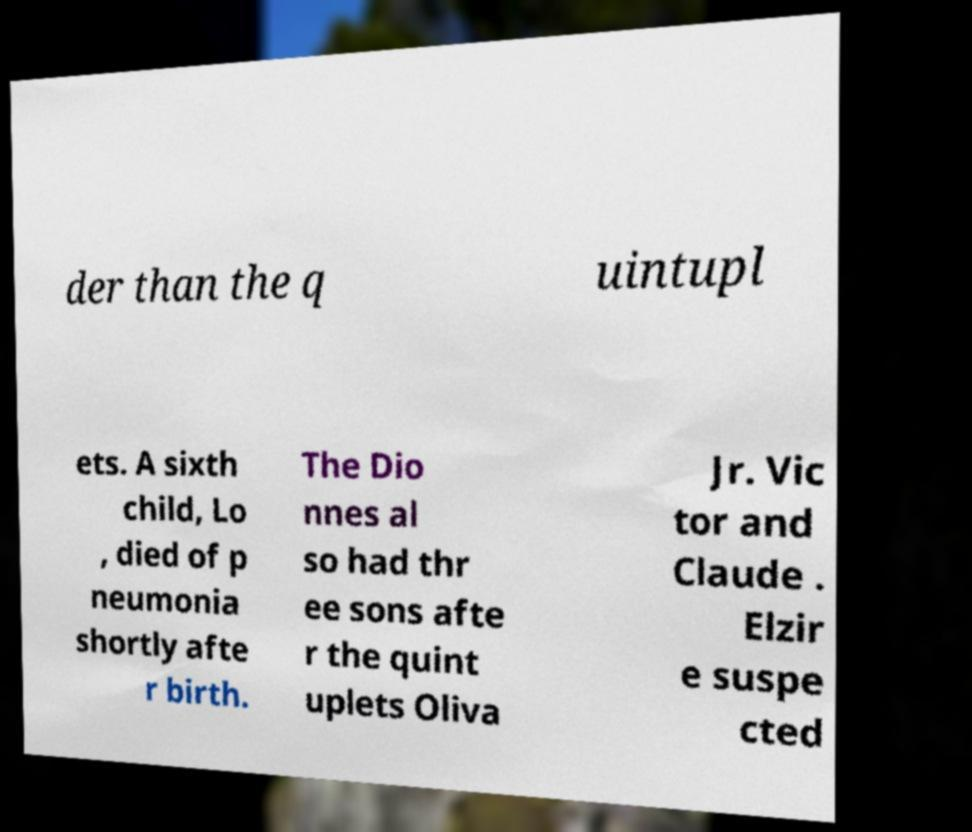There's text embedded in this image that I need extracted. Can you transcribe it verbatim? der than the q uintupl ets. A sixth child, Lo , died of p neumonia shortly afte r birth. The Dio nnes al so had thr ee sons afte r the quint uplets Oliva Jr. Vic tor and Claude . Elzir e suspe cted 